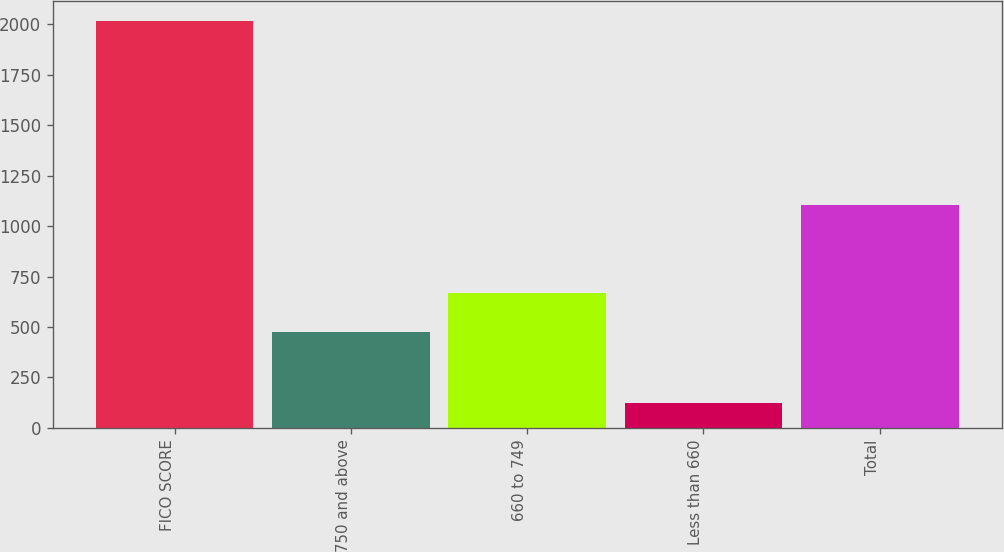Convert chart. <chart><loc_0><loc_0><loc_500><loc_500><bar_chart><fcel>FICO SCORE<fcel>750 and above<fcel>660 to 749<fcel>Less than 660<fcel>Total<nl><fcel>2017<fcel>477<fcel>666.6<fcel>121<fcel>1106<nl></chart> 